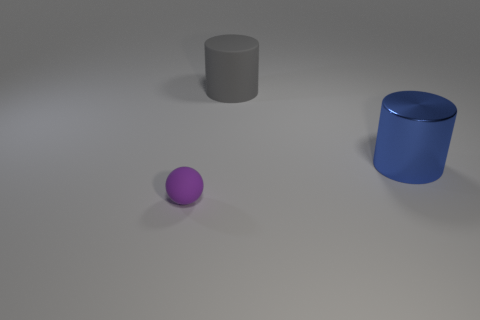The other object that is made of the same material as the big gray object is what shape?
Your answer should be compact. Sphere. There is a blue metal object; is it the same shape as the thing on the left side of the matte cylinder?
Provide a succinct answer. No. The cylinder on the right side of the cylinder to the left of the blue metallic cylinder is made of what material?
Ensure brevity in your answer.  Metal. What number of other objects are the same shape as the big blue thing?
Your response must be concise. 1. Do the matte object that is in front of the big blue shiny object and the matte object to the right of the tiny ball have the same shape?
Make the answer very short. No. Is there any other thing that has the same material as the small purple object?
Keep it short and to the point. Yes. What material is the tiny sphere?
Offer a terse response. Rubber. What is the material of the big cylinder in front of the big gray cylinder?
Offer a terse response. Metal. Is there anything else that has the same color as the large metal thing?
Your answer should be very brief. No. There is another thing that is the same material as the small object; what is its size?
Ensure brevity in your answer.  Large. 